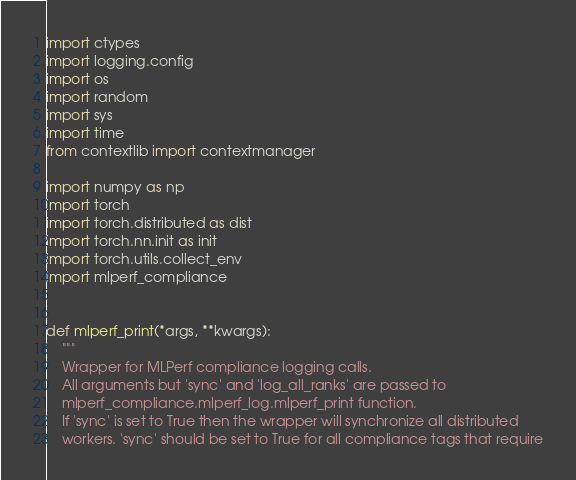Convert code to text. <code><loc_0><loc_0><loc_500><loc_500><_Python_>import ctypes
import logging.config
import os
import random
import sys
import time
from contextlib import contextmanager

import numpy as np
import torch
import torch.distributed as dist
import torch.nn.init as init
import torch.utils.collect_env
import mlperf_compliance


def mlperf_print(*args, **kwargs):
    """
    Wrapper for MLPerf compliance logging calls.
    All arguments but 'sync' and 'log_all_ranks' are passed to
    mlperf_compliance.mlperf_log.mlperf_print function.
    If 'sync' is set to True then the wrapper will synchronize all distributed
    workers. 'sync' should be set to True for all compliance tags that require</code> 